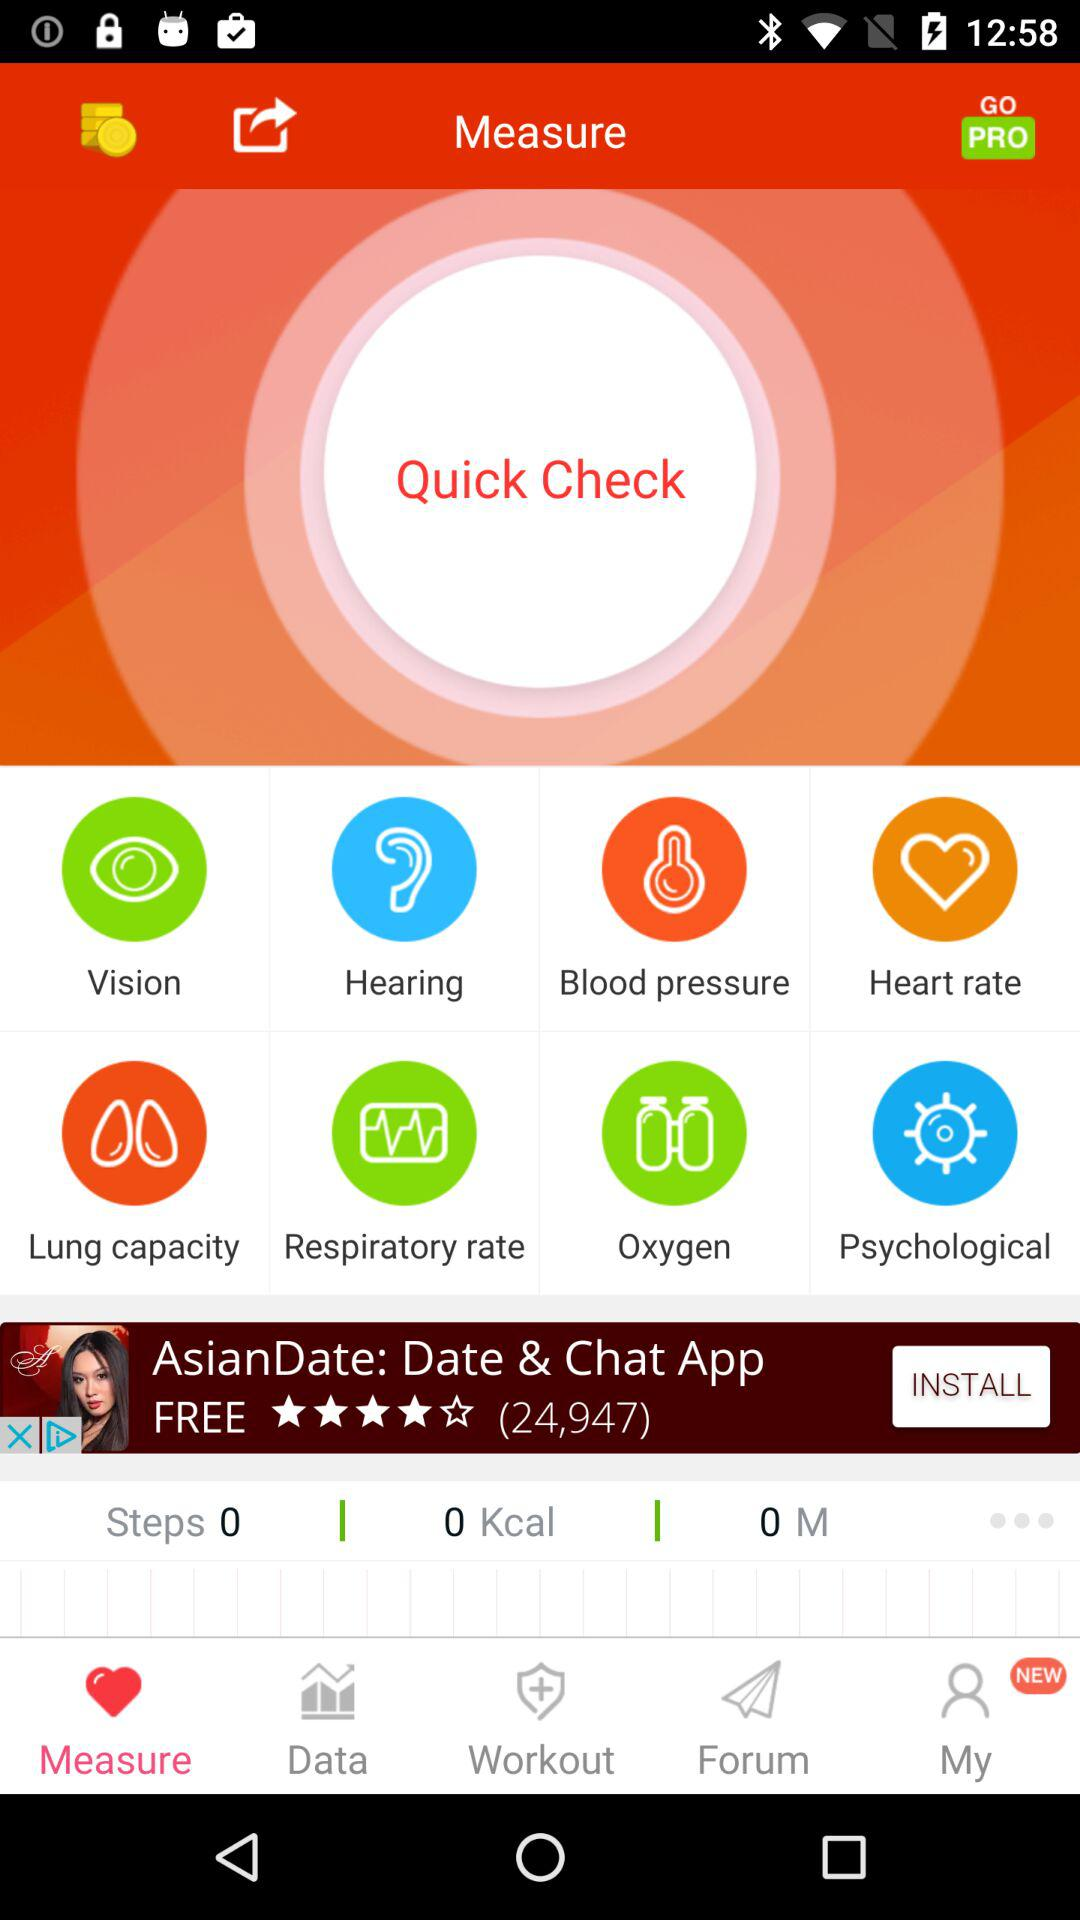How many steps are there?
Answer the question using a single word or phrase. 0 